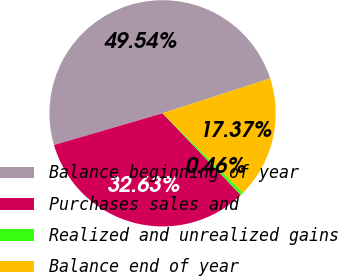Convert chart to OTSL. <chart><loc_0><loc_0><loc_500><loc_500><pie_chart><fcel>Balance beginning of year<fcel>Purchases sales and<fcel>Realized and unrealized gains<fcel>Balance end of year<nl><fcel>49.54%<fcel>32.63%<fcel>0.46%<fcel>17.37%<nl></chart> 